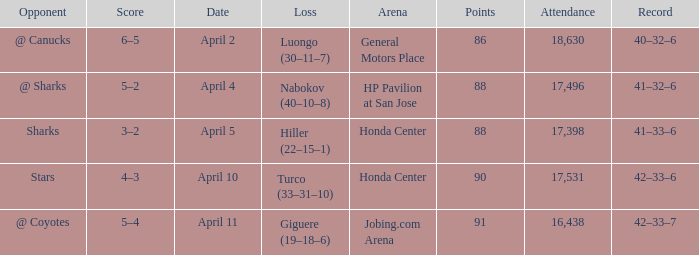Which Loss has a Record of 41–32–6? Nabokov (40–10–8). 